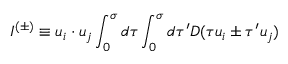Convert formula to latex. <formula><loc_0><loc_0><loc_500><loc_500>I ^ { ( \pm ) } \equiv u _ { i } \cdot u _ { j } \int _ { 0 } ^ { \sigma } d \tau \int _ { 0 } ^ { \sigma } d \tau ^ { \prime } D ( \tau u _ { i } \pm \tau ^ { \prime } u _ { j } )</formula> 